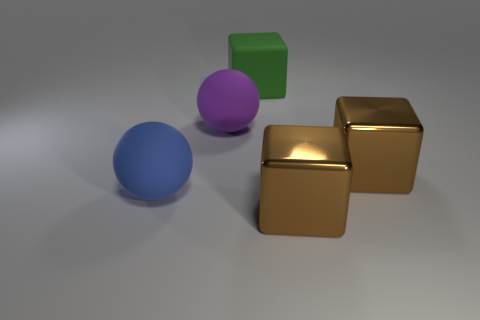Add 3 blue balls. How many objects exist? 8 Subtract all spheres. How many objects are left? 3 Subtract all large matte objects. Subtract all big purple things. How many objects are left? 1 Add 4 blue matte things. How many blue matte things are left? 5 Add 3 matte cubes. How many matte cubes exist? 4 Subtract 0 purple cylinders. How many objects are left? 5 